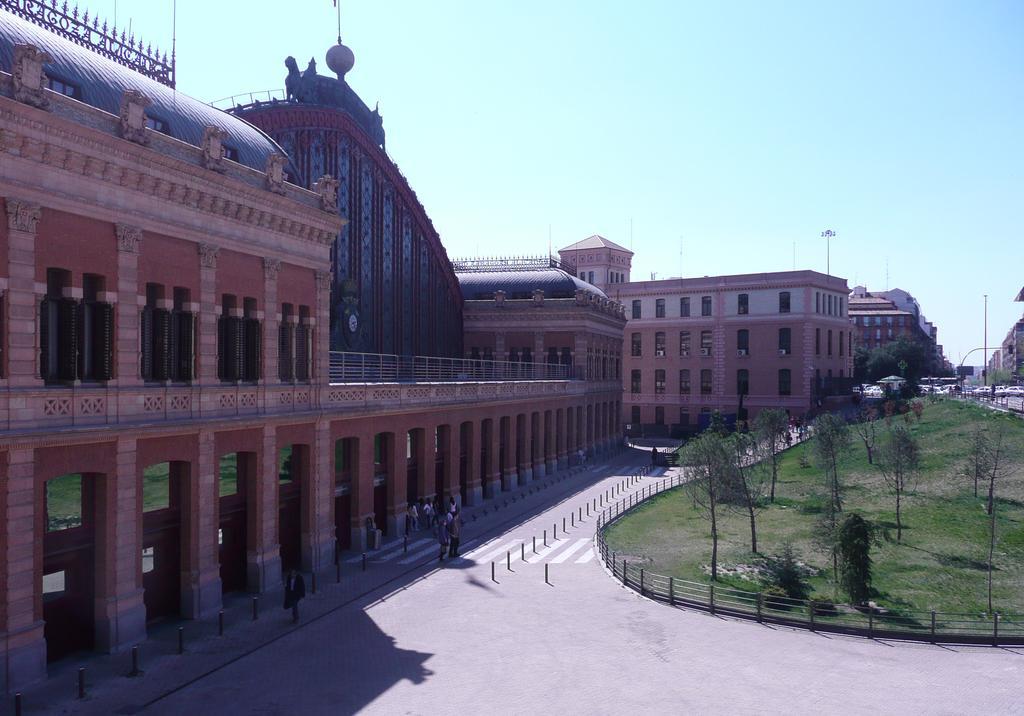Please provide a concise description of this image. In this image there is grassland having few trees surrounded by fence. Few persons are walking on the road. A person is walking on the pavement having poles. Right side there are few vehicles on the road. Background there are few buildings. Top of image there is sky. 